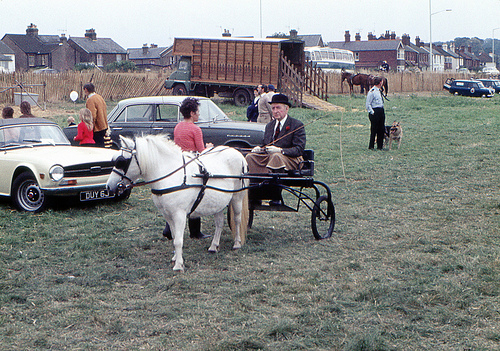Can you describe the horse in the image? Certainly! The horse in the image is white with a well-groomed coat, which catches the eye. It has a calm demeanor and is equipped with harnesses and reins for pulling the buggy. The horse appears to be of a smaller stature, which could indicate it is a pony breed known for its strength and ability to pull loads. Is there anything notable about how the buggy is designed? The buggy has a traditional design with spoke wheels and a seat that accommodates the driver. It looks lightweight and is likely designed for paved surfaces or well-maintained paths. The buggy's simplicity indicates it might be used for leisurely rides or as part of a collection reflective of historical transportation. 